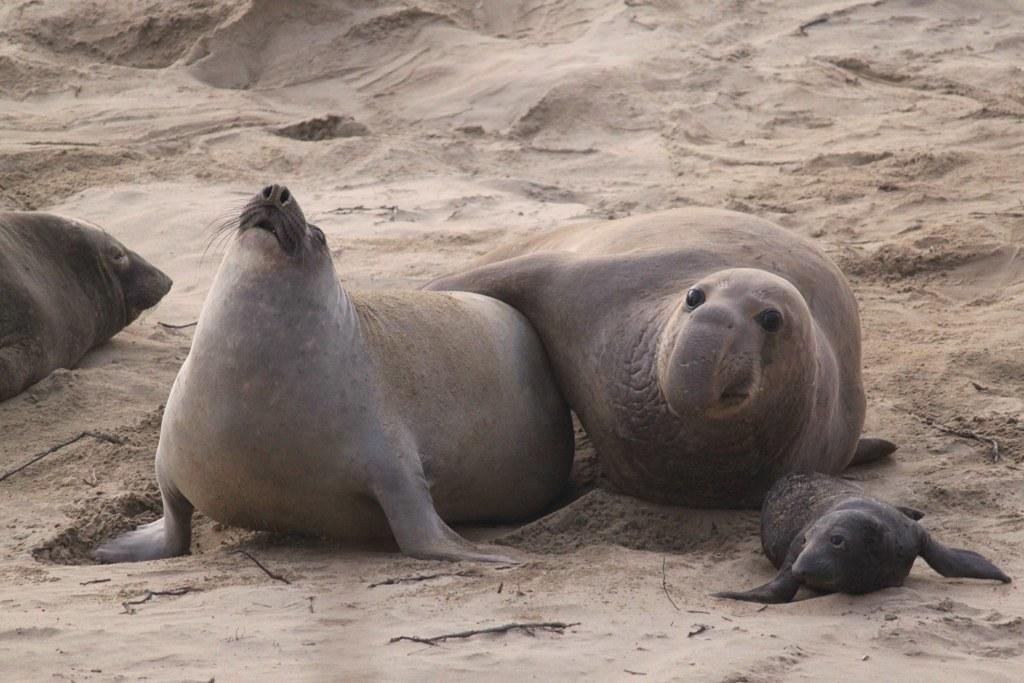What type of environment is depicted in the image? The image is an outside view that looks like a beach. What can be seen on the sand in the image? There are seals visible on the sand. What type of berry can be seen growing on the seals in the image? There are no berries visible on the seals in the image. What can be seen running through the veins of the seals in the image? There are no visible veins on the seals in the image, and nothing is running through them. 